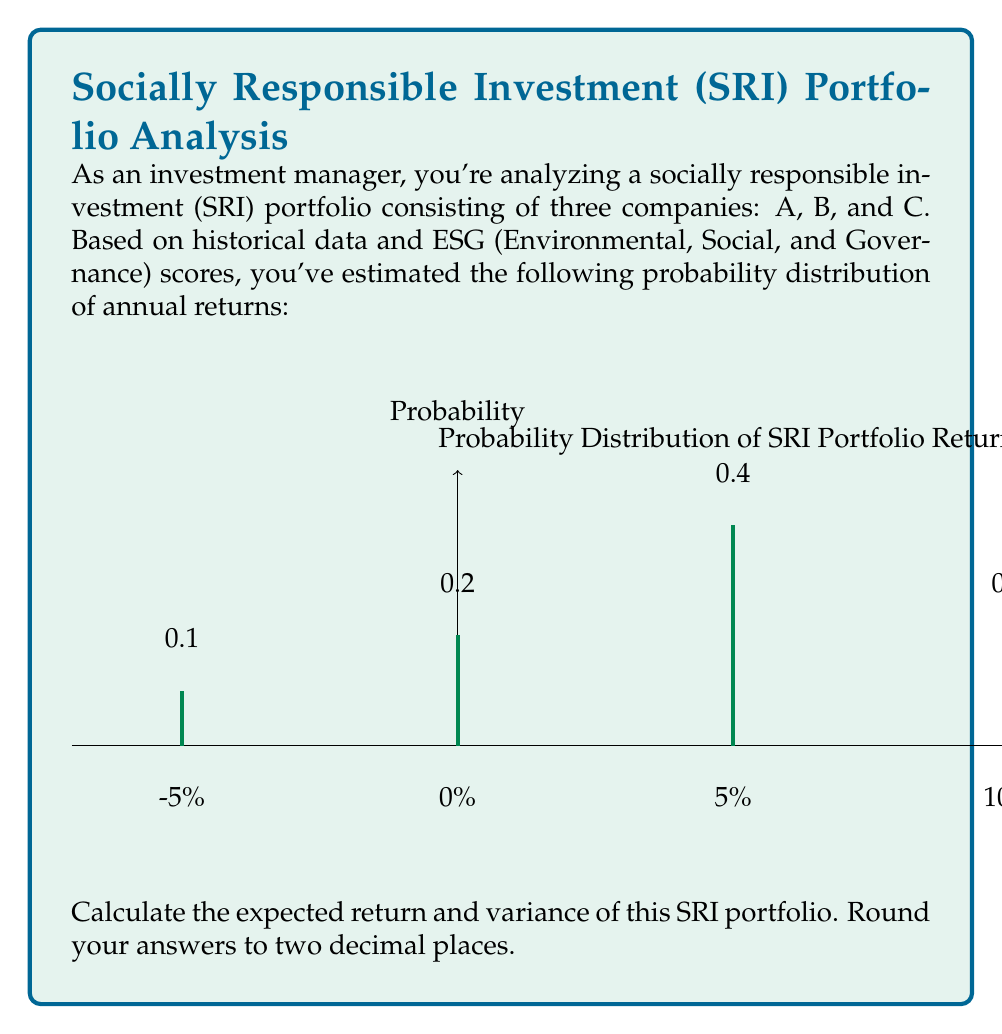Could you help me with this problem? To solve this problem, we'll follow these steps:

1. Calculate the expected return (mean)
2. Calculate the variance

Step 1: Expected Return (μ)
The expected return is calculated using the formula:

$$ \mu = E(X) = \sum_{i=1}^{n} x_i \cdot p(x_i) $$

Where $x_i$ are the possible returns and $p(x_i)$ are their corresponding probabilities.

$$ \mu = (-5 \cdot 0.1) + (0 \cdot 0.2) + (5 \cdot 0.4) + (10 \cdot 0.2) + (15 \cdot 0.1) $$
$$ \mu = -0.5 + 0 + 2 + 2 + 1.5 = 5 $$

Step 2: Variance (σ²)
The variance is calculated using the formula:

$$ \sigma^2 = E[(X - \mu)^2] = \sum_{i=1}^{n} (x_i - \mu)^2 \cdot p(x_i) $$

$$ \sigma^2 = (-5 - 5)^2 \cdot 0.1 + (0 - 5)^2 \cdot 0.2 + (5 - 5)^2 \cdot 0.4 + (10 - 5)^2 \cdot 0.2 + (15 - 5)^2 \cdot 0.1 $$
$$ \sigma^2 = 100 \cdot 0.1 + 25 \cdot 0.2 + 0 \cdot 0.4 + 25 \cdot 0.2 + 100 \cdot 0.1 $$
$$ \sigma^2 = 10 + 5 + 0 + 5 + 10 = 30 $$

Therefore, the expected return is 5% and the variance is 30.
Answer: Expected return: 5.00%, Variance: 30.00 